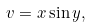Convert formula to latex. <formula><loc_0><loc_0><loc_500><loc_500>v = x \sin y ,</formula> 